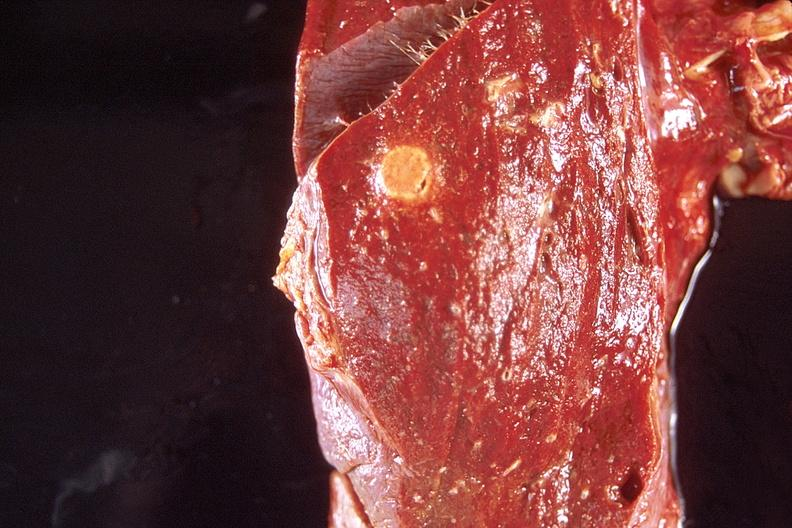s respiratory present?
Answer the question using a single word or phrase. Yes 